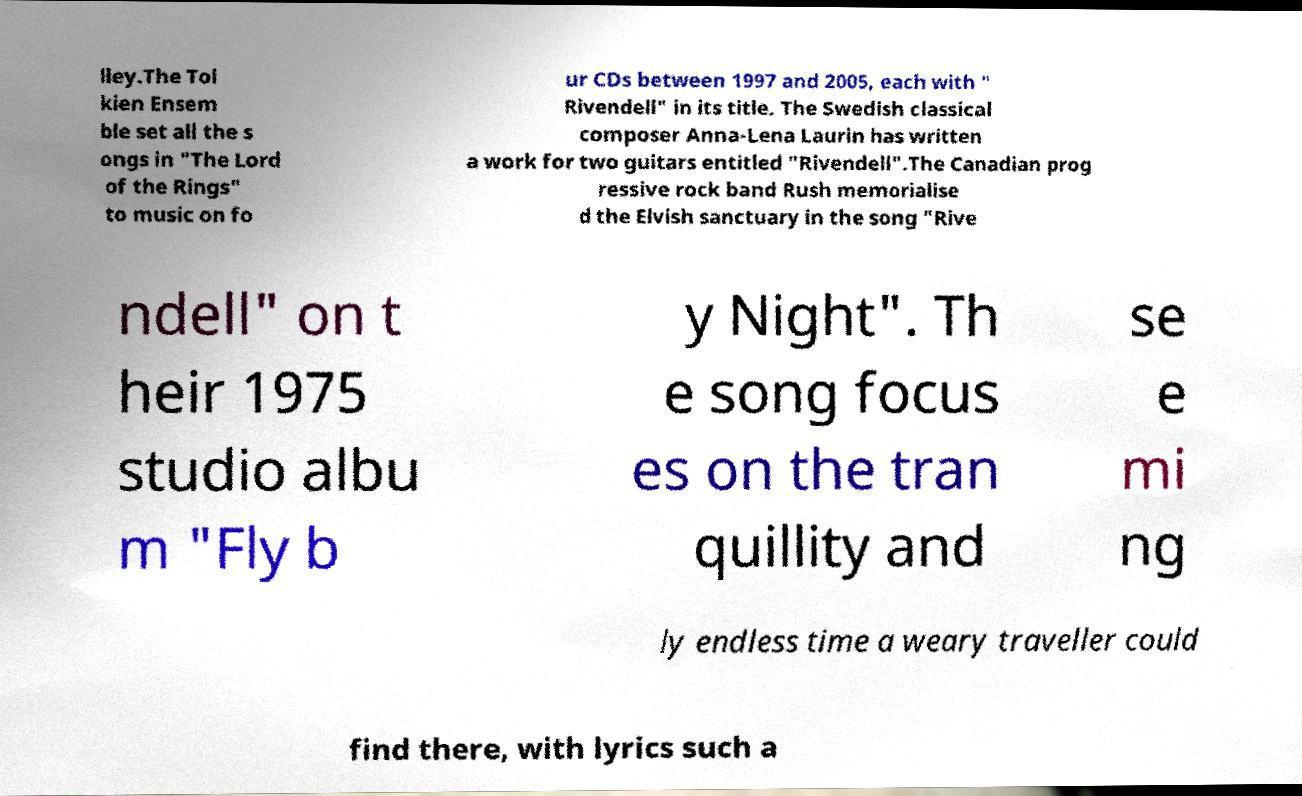Could you extract and type out the text from this image? lley.The Tol kien Ensem ble set all the s ongs in "The Lord of the Rings" to music on fo ur CDs between 1997 and 2005, each with " Rivendell" in its title. The Swedish classical composer Anna-Lena Laurin has written a work for two guitars entitled "Rivendell".The Canadian prog ressive rock band Rush memorialise d the Elvish sanctuary in the song "Rive ndell" on t heir 1975 studio albu m "Fly b y Night". Th e song focus es on the tran quillity and se e mi ng ly endless time a weary traveller could find there, with lyrics such a 